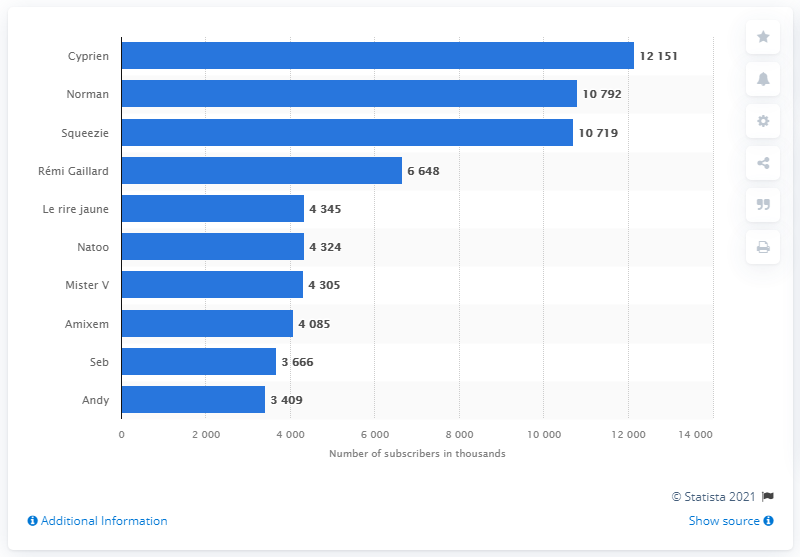Specify some key components in this picture. The most popular YouTube comedy channel in France is Cyprien. 